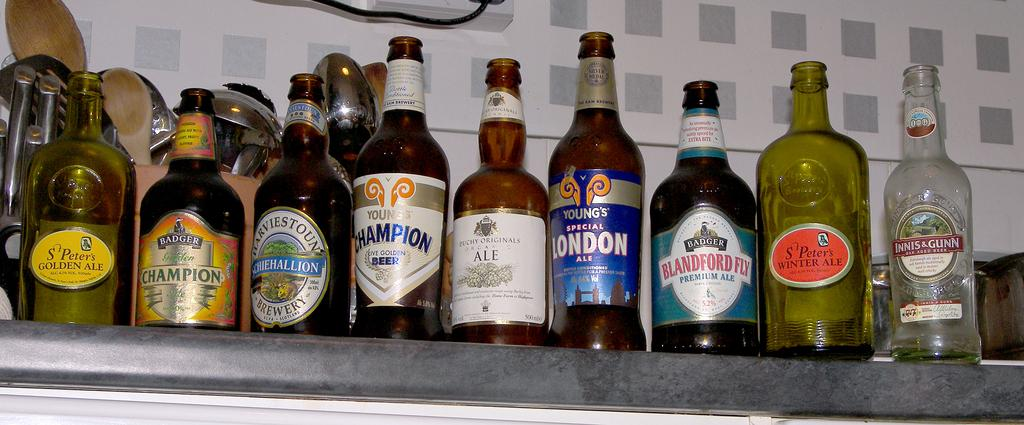<image>
Give a short and clear explanation of the subsequent image. Multiple empty alcohol bottles are lined up on a shelf, including Young's Special London ale. 